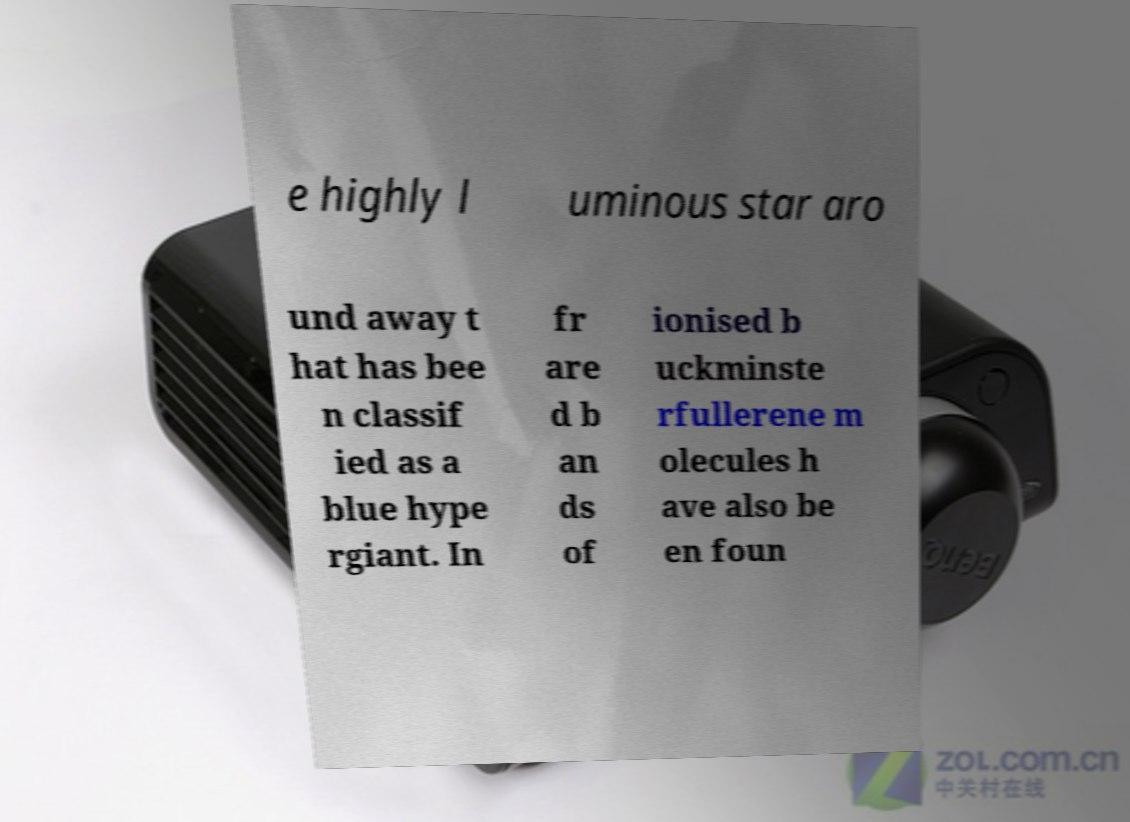Please read and relay the text visible in this image. What does it say? e highly l uminous star aro und away t hat has bee n classif ied as a blue hype rgiant. In fr are d b an ds of ionised b uckminste rfullerene m olecules h ave also be en foun 